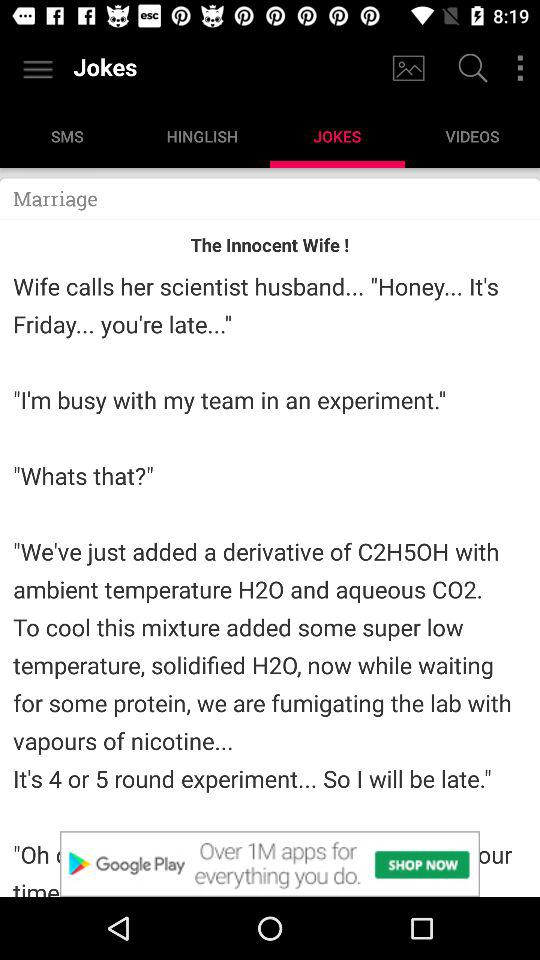Which tab has been selected? The tab that has been selected is "JOKES". 